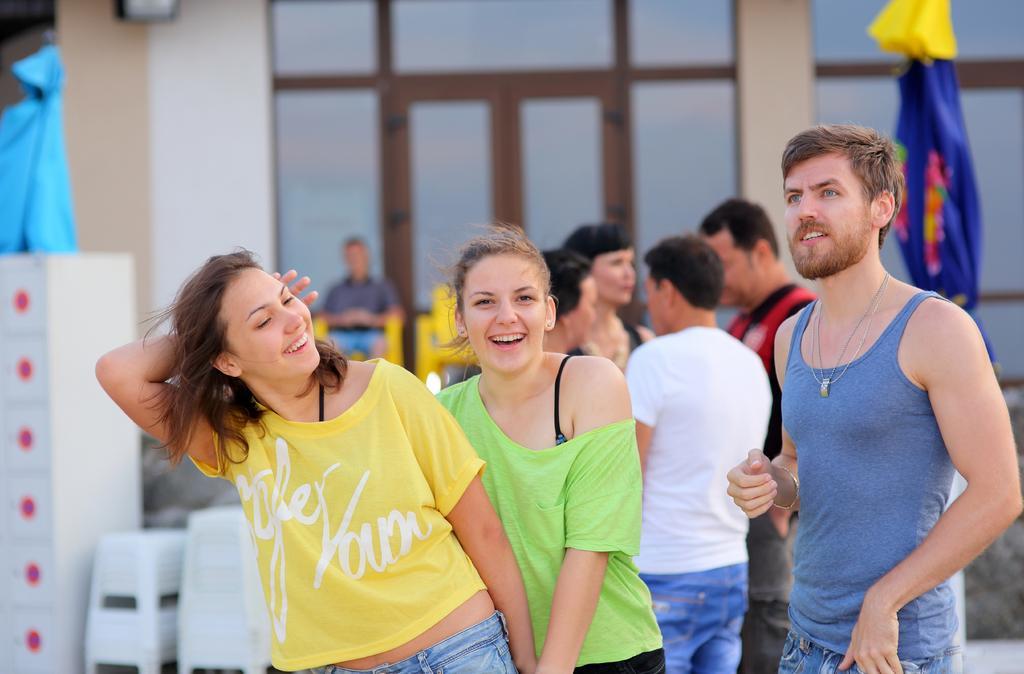Describe this image in one or two sentences. This picture seems to be clicked outside. In the center we can see the group of persons standing. In the background we can see a person sitting on a yellow color chair and there are some objects placed on the ground and we can see a building, cloth and some other objects. 